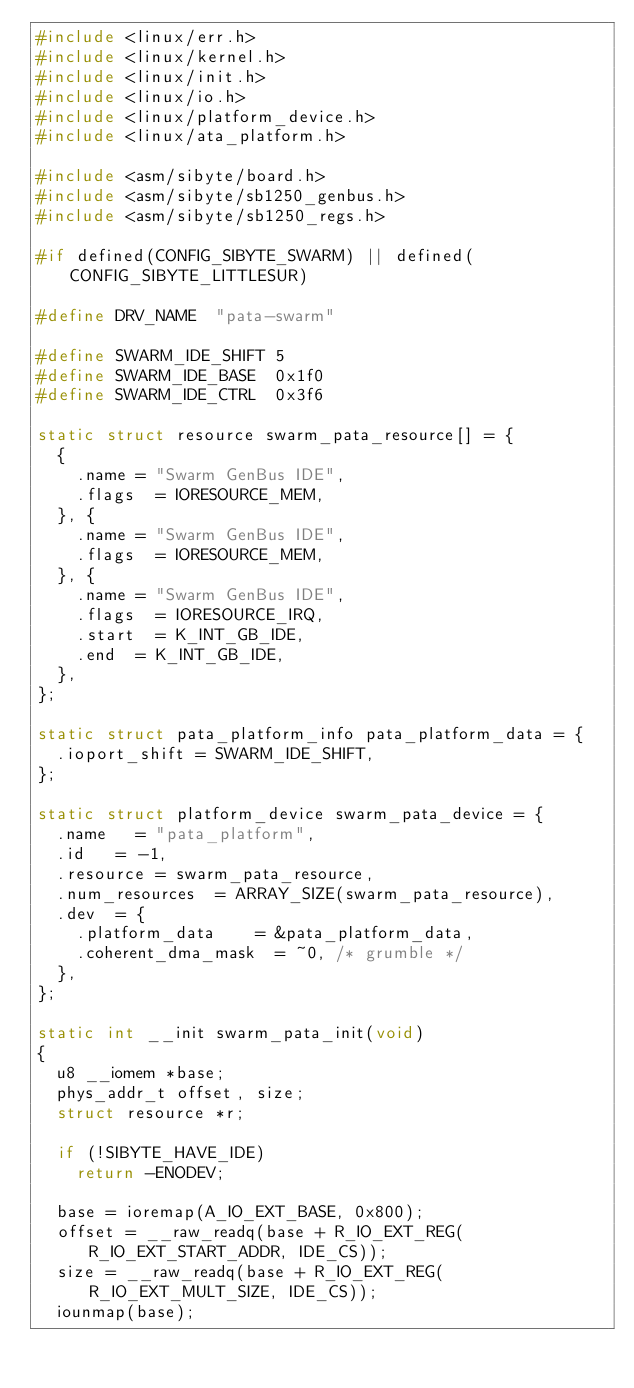<code> <loc_0><loc_0><loc_500><loc_500><_C_>#include <linux/err.h>
#include <linux/kernel.h>
#include <linux/init.h>
#include <linux/io.h>
#include <linux/platform_device.h>
#include <linux/ata_platform.h>

#include <asm/sibyte/board.h>
#include <asm/sibyte/sb1250_genbus.h>
#include <asm/sibyte/sb1250_regs.h>

#if defined(CONFIG_SIBYTE_SWARM) || defined(CONFIG_SIBYTE_LITTLESUR)

#define DRV_NAME	"pata-swarm"

#define SWARM_IDE_SHIFT 5
#define SWARM_IDE_BASE	0x1f0
#define SWARM_IDE_CTRL	0x3f6

static struct resource swarm_pata_resource[] = {
	{
		.name	= "Swarm GenBus IDE",
		.flags	= IORESOURCE_MEM,
	}, {
		.name	= "Swarm GenBus IDE",
		.flags	= IORESOURCE_MEM,
	}, {
		.name	= "Swarm GenBus IDE",
		.flags	= IORESOURCE_IRQ,
		.start	= K_INT_GB_IDE,
		.end	= K_INT_GB_IDE,
	},
};

static struct pata_platform_info pata_platform_data = {
	.ioport_shift	= SWARM_IDE_SHIFT,
};

static struct platform_device swarm_pata_device = {
	.name		= "pata_platform",
	.id		= -1,
	.resource	= swarm_pata_resource,
	.num_resources	= ARRAY_SIZE(swarm_pata_resource),
	.dev  = {
		.platform_data		= &pata_platform_data,
		.coherent_dma_mask	= ~0,	/* grumble */
	},
};

static int __init swarm_pata_init(void)
{
	u8 __iomem *base;
	phys_addr_t offset, size;
	struct resource *r;

	if (!SIBYTE_HAVE_IDE)
		return -ENODEV;

	base = ioremap(A_IO_EXT_BASE, 0x800);
	offset = __raw_readq(base + R_IO_EXT_REG(R_IO_EXT_START_ADDR, IDE_CS));
	size = __raw_readq(base + R_IO_EXT_REG(R_IO_EXT_MULT_SIZE, IDE_CS));
	iounmap(base);
</code> 